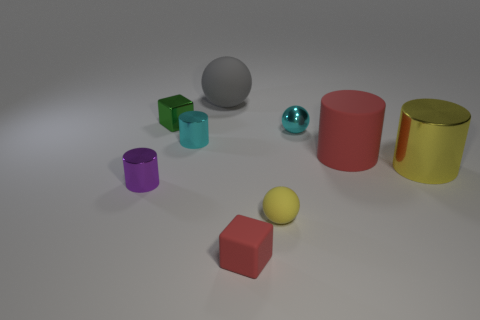There is a metal cylinder that is left of the tiny shiny ball and on the right side of the purple object; what is its size?
Provide a succinct answer. Small. Is there any other thing that has the same material as the gray sphere?
Give a very brief answer. Yes. Is the big gray object made of the same material as the cylinder that is to the right of the big matte cylinder?
Provide a short and direct response. No. Are there fewer metallic objects on the left side of the red cylinder than rubber cylinders in front of the tiny red block?
Make the answer very short. No. There is a cylinder that is in front of the big metallic cylinder; what material is it?
Offer a terse response. Metal. There is a shiny cylinder that is behind the purple metal cylinder and to the left of the yellow cylinder; what color is it?
Provide a succinct answer. Cyan. How many other things are there of the same color as the shiny cube?
Keep it short and to the point. 0. What color is the block on the right side of the tiny cyan metal cylinder?
Your response must be concise. Red. Is there a cyan cylinder that has the same size as the yellow rubber object?
Provide a short and direct response. Yes. There is a green thing that is the same size as the cyan metallic cylinder; what is it made of?
Give a very brief answer. Metal. 